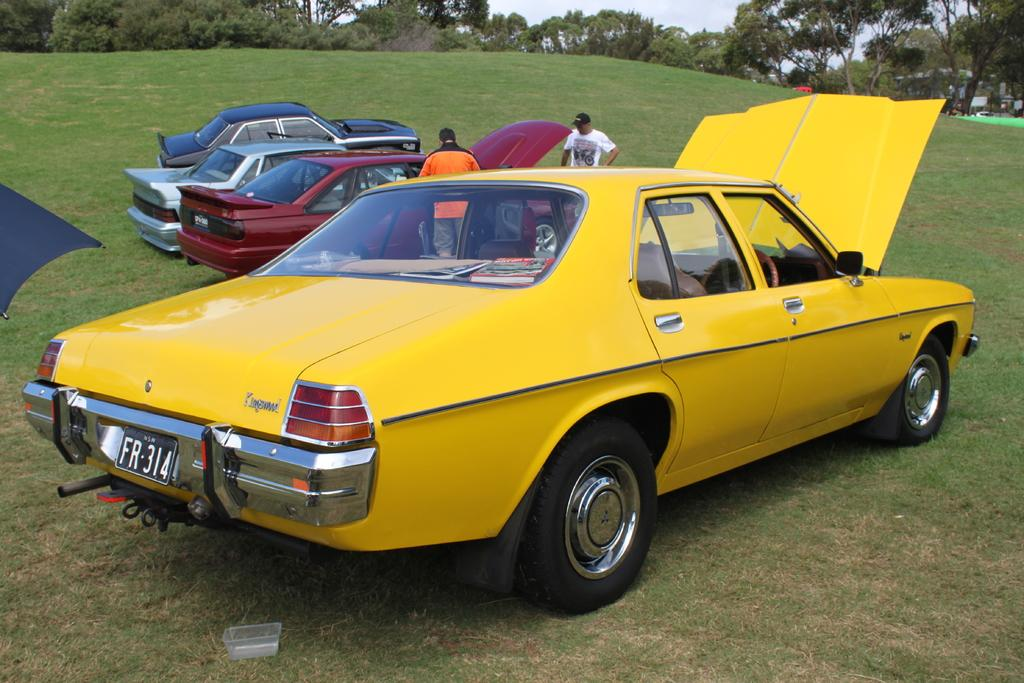How many people are in the image? There are two people in the image. What else can be seen in the image besides the people? There are cars, grass, trees, and the sky visible in the image. Can you describe the natural elements in the image? There is grass and trees present in the image. What is visible at the top of the image? The sky is visible at the top of the image. What type of net can be seen in the image? There is no net present in the image. How far is the range of the cars in the image? The range of the cars cannot be determined from the image, as it only shows the cars and not their movement or distance traveled. 